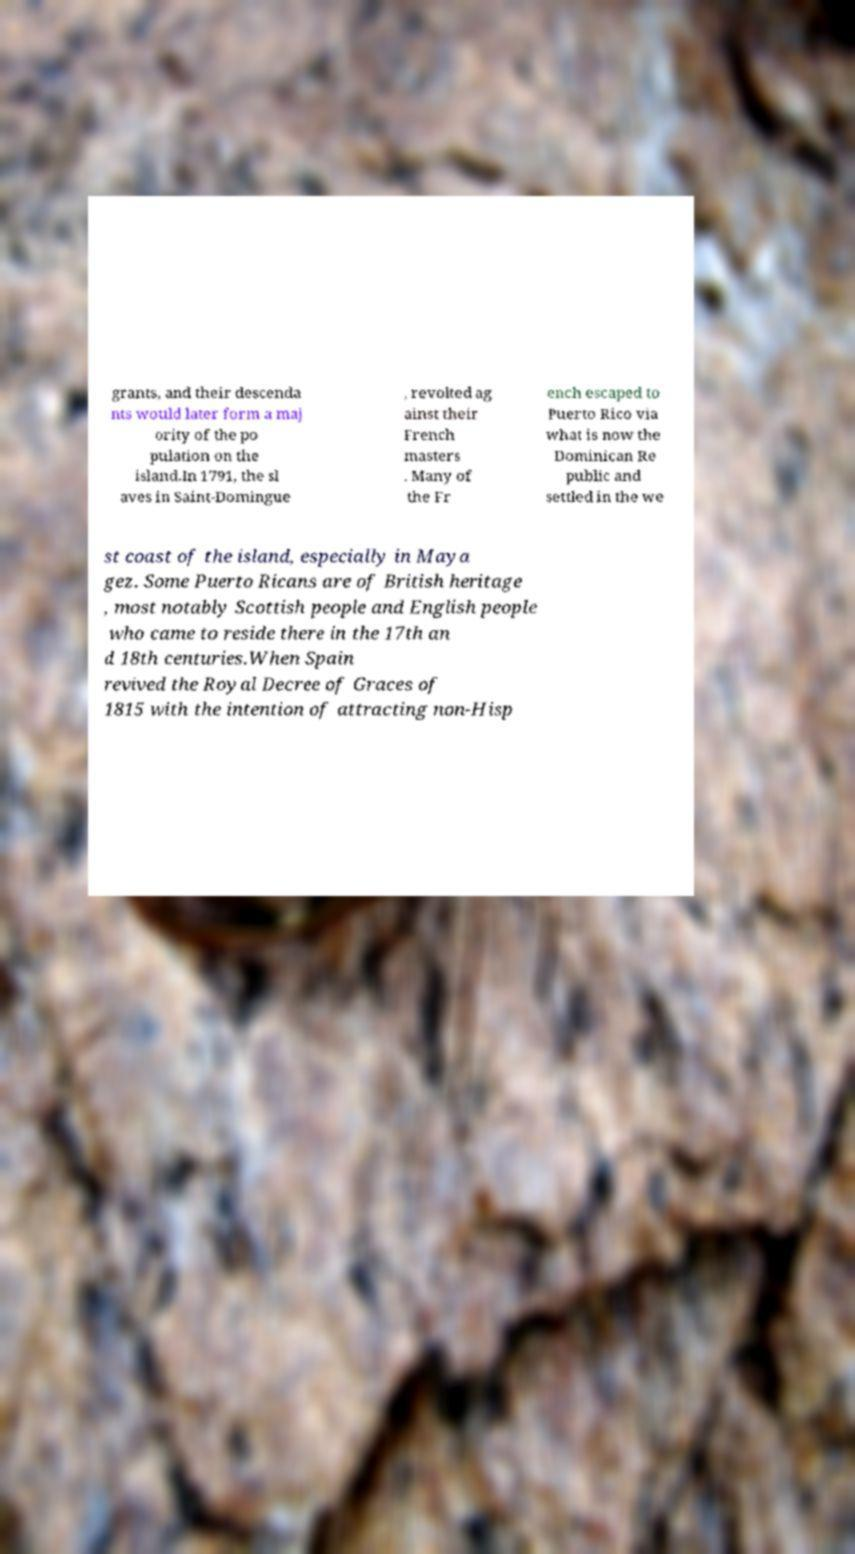Could you extract and type out the text from this image? grants, and their descenda nts would later form a maj ority of the po pulation on the island.In 1791, the sl aves in Saint-Domingue , revolted ag ainst their French masters . Many of the Fr ench escaped to Puerto Rico via what is now the Dominican Re public and settled in the we st coast of the island, especially in Maya gez. Some Puerto Ricans are of British heritage , most notably Scottish people and English people who came to reside there in the 17th an d 18th centuries.When Spain revived the Royal Decree of Graces of 1815 with the intention of attracting non-Hisp 